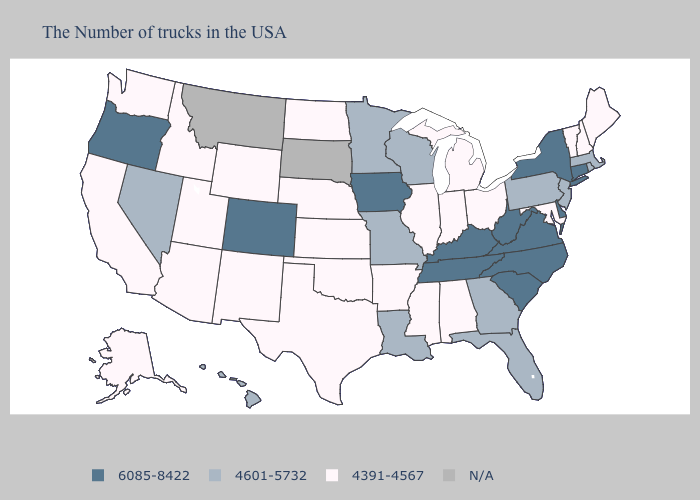What is the lowest value in the South?
Short answer required. 4391-4567. Name the states that have a value in the range 4601-5732?
Write a very short answer. Massachusetts, Rhode Island, New Jersey, Pennsylvania, Florida, Georgia, Wisconsin, Louisiana, Missouri, Minnesota, Nevada, Hawaii. Name the states that have a value in the range N/A?
Write a very short answer. South Dakota, Montana. Name the states that have a value in the range 6085-8422?
Short answer required. Connecticut, New York, Delaware, Virginia, North Carolina, South Carolina, West Virginia, Kentucky, Tennessee, Iowa, Colorado, Oregon. Is the legend a continuous bar?
Write a very short answer. No. What is the value of Montana?
Be succinct. N/A. Among the states that border Oklahoma , does Texas have the lowest value?
Be succinct. Yes. Does Tennessee have the highest value in the USA?
Be succinct. Yes. What is the value of Mississippi?
Quick response, please. 4391-4567. Name the states that have a value in the range 6085-8422?
Keep it brief. Connecticut, New York, Delaware, Virginia, North Carolina, South Carolina, West Virginia, Kentucky, Tennessee, Iowa, Colorado, Oregon. Name the states that have a value in the range 6085-8422?
Keep it brief. Connecticut, New York, Delaware, Virginia, North Carolina, South Carolina, West Virginia, Kentucky, Tennessee, Iowa, Colorado, Oregon. What is the highest value in states that border Illinois?
Be succinct. 6085-8422. Does Nevada have the lowest value in the USA?
Give a very brief answer. No. What is the value of Georgia?
Be succinct. 4601-5732. 